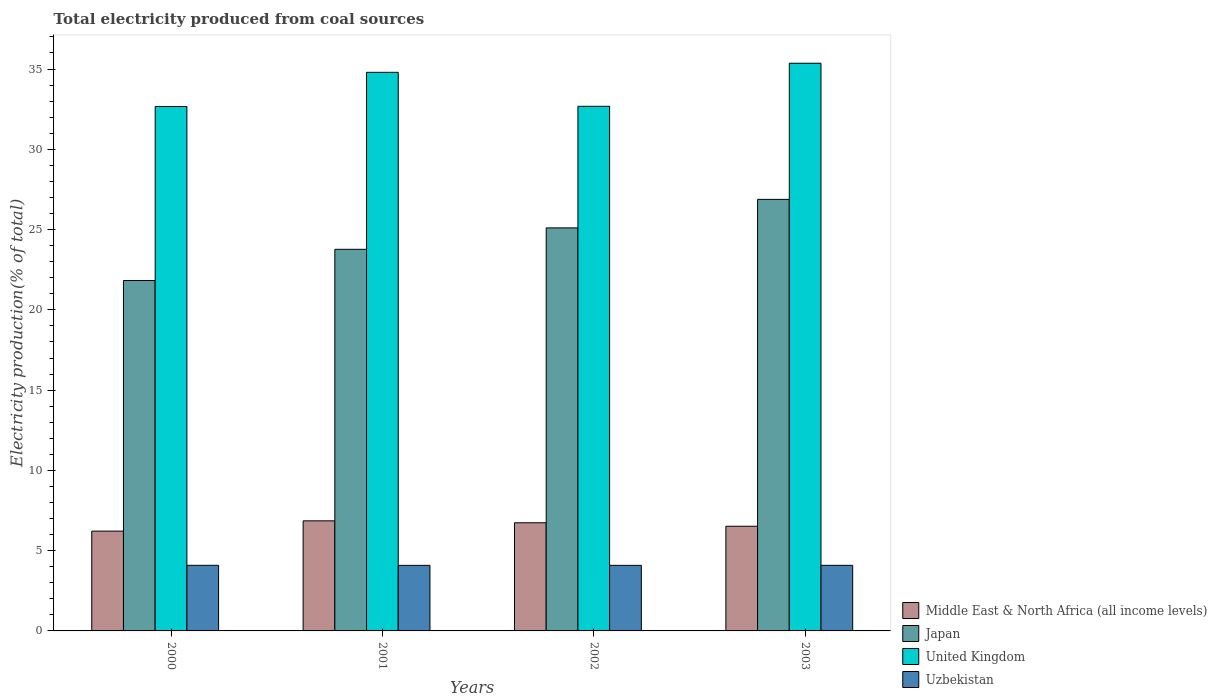How many different coloured bars are there?
Provide a succinct answer. 4. How many groups of bars are there?
Ensure brevity in your answer.  4. Are the number of bars on each tick of the X-axis equal?
Ensure brevity in your answer.  Yes. In how many cases, is the number of bars for a given year not equal to the number of legend labels?
Your answer should be very brief. 0. What is the total electricity produced in Middle East & North Africa (all income levels) in 2001?
Ensure brevity in your answer.  6.86. Across all years, what is the maximum total electricity produced in Japan?
Give a very brief answer. 26.88. Across all years, what is the minimum total electricity produced in Uzbekistan?
Your answer should be compact. 4.08. In which year was the total electricity produced in Uzbekistan maximum?
Ensure brevity in your answer.  2000. What is the total total electricity produced in United Kingdom in the graph?
Keep it short and to the point. 135.5. What is the difference between the total electricity produced in United Kingdom in 2001 and that in 2002?
Make the answer very short. 2.12. What is the difference between the total electricity produced in Japan in 2000 and the total electricity produced in United Kingdom in 2001?
Your answer should be very brief. -12.97. What is the average total electricity produced in Middle East & North Africa (all income levels) per year?
Make the answer very short. 6.58. In the year 2002, what is the difference between the total electricity produced in United Kingdom and total electricity produced in Japan?
Provide a succinct answer. 7.57. In how many years, is the total electricity produced in Uzbekistan greater than 10 %?
Provide a succinct answer. 0. What is the ratio of the total electricity produced in Uzbekistan in 2000 to that in 2002?
Keep it short and to the point. 1. Is the total electricity produced in United Kingdom in 2002 less than that in 2003?
Provide a succinct answer. Yes. What is the difference between the highest and the second highest total electricity produced in Japan?
Offer a terse response. 1.78. What is the difference between the highest and the lowest total electricity produced in United Kingdom?
Provide a succinct answer. 2.69. Is it the case that in every year, the sum of the total electricity produced in Middle East & North Africa (all income levels) and total electricity produced in Uzbekistan is greater than the sum of total electricity produced in United Kingdom and total electricity produced in Japan?
Make the answer very short. No. What does the 1st bar from the right in 2001 represents?
Your answer should be compact. Uzbekistan. Are all the bars in the graph horizontal?
Provide a short and direct response. No. What is the difference between two consecutive major ticks on the Y-axis?
Keep it short and to the point. 5. Are the values on the major ticks of Y-axis written in scientific E-notation?
Your answer should be compact. No. Does the graph contain any zero values?
Provide a short and direct response. No. Does the graph contain grids?
Ensure brevity in your answer.  No. Where does the legend appear in the graph?
Your answer should be compact. Bottom right. How many legend labels are there?
Provide a succinct answer. 4. What is the title of the graph?
Provide a short and direct response. Total electricity produced from coal sources. What is the Electricity production(% of total) in Middle East & North Africa (all income levels) in 2000?
Your response must be concise. 6.22. What is the Electricity production(% of total) of Japan in 2000?
Provide a short and direct response. 21.83. What is the Electricity production(% of total) in United Kingdom in 2000?
Provide a short and direct response. 32.67. What is the Electricity production(% of total) of Uzbekistan in 2000?
Give a very brief answer. 4.09. What is the Electricity production(% of total) of Middle East & North Africa (all income levels) in 2001?
Give a very brief answer. 6.86. What is the Electricity production(% of total) of Japan in 2001?
Your answer should be compact. 23.77. What is the Electricity production(% of total) of United Kingdom in 2001?
Ensure brevity in your answer.  34.8. What is the Electricity production(% of total) in Uzbekistan in 2001?
Keep it short and to the point. 4.08. What is the Electricity production(% of total) of Middle East & North Africa (all income levels) in 2002?
Give a very brief answer. 6.74. What is the Electricity production(% of total) of Japan in 2002?
Your response must be concise. 25.11. What is the Electricity production(% of total) in United Kingdom in 2002?
Make the answer very short. 32.68. What is the Electricity production(% of total) of Uzbekistan in 2002?
Make the answer very short. 4.08. What is the Electricity production(% of total) of Middle East & North Africa (all income levels) in 2003?
Make the answer very short. 6.52. What is the Electricity production(% of total) in Japan in 2003?
Offer a very short reply. 26.88. What is the Electricity production(% of total) of United Kingdom in 2003?
Offer a terse response. 35.36. What is the Electricity production(% of total) in Uzbekistan in 2003?
Your response must be concise. 4.09. Across all years, what is the maximum Electricity production(% of total) in Middle East & North Africa (all income levels)?
Offer a terse response. 6.86. Across all years, what is the maximum Electricity production(% of total) of Japan?
Ensure brevity in your answer.  26.88. Across all years, what is the maximum Electricity production(% of total) in United Kingdom?
Make the answer very short. 35.36. Across all years, what is the maximum Electricity production(% of total) of Uzbekistan?
Offer a very short reply. 4.09. Across all years, what is the minimum Electricity production(% of total) of Middle East & North Africa (all income levels)?
Make the answer very short. 6.22. Across all years, what is the minimum Electricity production(% of total) of Japan?
Your answer should be very brief. 21.83. Across all years, what is the minimum Electricity production(% of total) in United Kingdom?
Your answer should be compact. 32.67. Across all years, what is the minimum Electricity production(% of total) of Uzbekistan?
Give a very brief answer. 4.08. What is the total Electricity production(% of total) of Middle East & North Africa (all income levels) in the graph?
Keep it short and to the point. 26.33. What is the total Electricity production(% of total) of Japan in the graph?
Keep it short and to the point. 97.59. What is the total Electricity production(% of total) of United Kingdom in the graph?
Ensure brevity in your answer.  135.5. What is the total Electricity production(% of total) of Uzbekistan in the graph?
Offer a terse response. 16.34. What is the difference between the Electricity production(% of total) of Middle East & North Africa (all income levels) in 2000 and that in 2001?
Keep it short and to the point. -0.64. What is the difference between the Electricity production(% of total) of Japan in 2000 and that in 2001?
Offer a terse response. -1.94. What is the difference between the Electricity production(% of total) of United Kingdom in 2000 and that in 2001?
Make the answer very short. -2.13. What is the difference between the Electricity production(% of total) of Uzbekistan in 2000 and that in 2001?
Your response must be concise. 0. What is the difference between the Electricity production(% of total) in Middle East & North Africa (all income levels) in 2000 and that in 2002?
Provide a succinct answer. -0.52. What is the difference between the Electricity production(% of total) of Japan in 2000 and that in 2002?
Make the answer very short. -3.28. What is the difference between the Electricity production(% of total) of United Kingdom in 2000 and that in 2002?
Offer a terse response. -0.01. What is the difference between the Electricity production(% of total) of Uzbekistan in 2000 and that in 2002?
Ensure brevity in your answer.  0. What is the difference between the Electricity production(% of total) of Middle East & North Africa (all income levels) in 2000 and that in 2003?
Your answer should be very brief. -0.3. What is the difference between the Electricity production(% of total) in Japan in 2000 and that in 2003?
Your answer should be compact. -5.05. What is the difference between the Electricity production(% of total) in United Kingdom in 2000 and that in 2003?
Your response must be concise. -2.69. What is the difference between the Electricity production(% of total) in Uzbekistan in 2000 and that in 2003?
Your answer should be very brief. 0. What is the difference between the Electricity production(% of total) of Middle East & North Africa (all income levels) in 2001 and that in 2002?
Your response must be concise. 0.12. What is the difference between the Electricity production(% of total) in Japan in 2001 and that in 2002?
Keep it short and to the point. -1.33. What is the difference between the Electricity production(% of total) of United Kingdom in 2001 and that in 2002?
Provide a succinct answer. 2.12. What is the difference between the Electricity production(% of total) of Uzbekistan in 2001 and that in 2002?
Ensure brevity in your answer.  -0. What is the difference between the Electricity production(% of total) of Middle East & North Africa (all income levels) in 2001 and that in 2003?
Give a very brief answer. 0.34. What is the difference between the Electricity production(% of total) in Japan in 2001 and that in 2003?
Offer a very short reply. -3.11. What is the difference between the Electricity production(% of total) in United Kingdom in 2001 and that in 2003?
Your answer should be very brief. -0.56. What is the difference between the Electricity production(% of total) in Uzbekistan in 2001 and that in 2003?
Provide a short and direct response. -0. What is the difference between the Electricity production(% of total) in Middle East & North Africa (all income levels) in 2002 and that in 2003?
Make the answer very short. 0.22. What is the difference between the Electricity production(% of total) of Japan in 2002 and that in 2003?
Your response must be concise. -1.78. What is the difference between the Electricity production(% of total) in United Kingdom in 2002 and that in 2003?
Make the answer very short. -2.68. What is the difference between the Electricity production(% of total) in Uzbekistan in 2002 and that in 2003?
Keep it short and to the point. -0. What is the difference between the Electricity production(% of total) in Middle East & North Africa (all income levels) in 2000 and the Electricity production(% of total) in Japan in 2001?
Offer a very short reply. -17.55. What is the difference between the Electricity production(% of total) of Middle East & North Africa (all income levels) in 2000 and the Electricity production(% of total) of United Kingdom in 2001?
Your response must be concise. -28.58. What is the difference between the Electricity production(% of total) of Middle East & North Africa (all income levels) in 2000 and the Electricity production(% of total) of Uzbekistan in 2001?
Your response must be concise. 2.13. What is the difference between the Electricity production(% of total) of Japan in 2000 and the Electricity production(% of total) of United Kingdom in 2001?
Provide a short and direct response. -12.97. What is the difference between the Electricity production(% of total) in Japan in 2000 and the Electricity production(% of total) in Uzbekistan in 2001?
Your answer should be very brief. 17.74. What is the difference between the Electricity production(% of total) of United Kingdom in 2000 and the Electricity production(% of total) of Uzbekistan in 2001?
Ensure brevity in your answer.  28.58. What is the difference between the Electricity production(% of total) in Middle East & North Africa (all income levels) in 2000 and the Electricity production(% of total) in Japan in 2002?
Make the answer very short. -18.89. What is the difference between the Electricity production(% of total) of Middle East & North Africa (all income levels) in 2000 and the Electricity production(% of total) of United Kingdom in 2002?
Keep it short and to the point. -26.46. What is the difference between the Electricity production(% of total) in Middle East & North Africa (all income levels) in 2000 and the Electricity production(% of total) in Uzbekistan in 2002?
Your response must be concise. 2.13. What is the difference between the Electricity production(% of total) of Japan in 2000 and the Electricity production(% of total) of United Kingdom in 2002?
Offer a very short reply. -10.85. What is the difference between the Electricity production(% of total) of Japan in 2000 and the Electricity production(% of total) of Uzbekistan in 2002?
Make the answer very short. 17.74. What is the difference between the Electricity production(% of total) in United Kingdom in 2000 and the Electricity production(% of total) in Uzbekistan in 2002?
Your answer should be compact. 28.58. What is the difference between the Electricity production(% of total) in Middle East & North Africa (all income levels) in 2000 and the Electricity production(% of total) in Japan in 2003?
Keep it short and to the point. -20.66. What is the difference between the Electricity production(% of total) in Middle East & North Africa (all income levels) in 2000 and the Electricity production(% of total) in United Kingdom in 2003?
Your response must be concise. -29.14. What is the difference between the Electricity production(% of total) of Middle East & North Africa (all income levels) in 2000 and the Electricity production(% of total) of Uzbekistan in 2003?
Provide a short and direct response. 2.13. What is the difference between the Electricity production(% of total) of Japan in 2000 and the Electricity production(% of total) of United Kingdom in 2003?
Offer a very short reply. -13.53. What is the difference between the Electricity production(% of total) in Japan in 2000 and the Electricity production(% of total) in Uzbekistan in 2003?
Provide a succinct answer. 17.74. What is the difference between the Electricity production(% of total) in United Kingdom in 2000 and the Electricity production(% of total) in Uzbekistan in 2003?
Give a very brief answer. 28.58. What is the difference between the Electricity production(% of total) of Middle East & North Africa (all income levels) in 2001 and the Electricity production(% of total) of Japan in 2002?
Offer a very short reply. -18.25. What is the difference between the Electricity production(% of total) of Middle East & North Africa (all income levels) in 2001 and the Electricity production(% of total) of United Kingdom in 2002?
Your answer should be compact. -25.82. What is the difference between the Electricity production(% of total) in Middle East & North Africa (all income levels) in 2001 and the Electricity production(% of total) in Uzbekistan in 2002?
Provide a succinct answer. 2.77. What is the difference between the Electricity production(% of total) in Japan in 2001 and the Electricity production(% of total) in United Kingdom in 2002?
Make the answer very short. -8.91. What is the difference between the Electricity production(% of total) of Japan in 2001 and the Electricity production(% of total) of Uzbekistan in 2002?
Your answer should be compact. 19.69. What is the difference between the Electricity production(% of total) in United Kingdom in 2001 and the Electricity production(% of total) in Uzbekistan in 2002?
Provide a short and direct response. 30.71. What is the difference between the Electricity production(% of total) in Middle East & North Africa (all income levels) in 2001 and the Electricity production(% of total) in Japan in 2003?
Offer a terse response. -20.02. What is the difference between the Electricity production(% of total) in Middle East & North Africa (all income levels) in 2001 and the Electricity production(% of total) in United Kingdom in 2003?
Make the answer very short. -28.5. What is the difference between the Electricity production(% of total) in Middle East & North Africa (all income levels) in 2001 and the Electricity production(% of total) in Uzbekistan in 2003?
Your answer should be compact. 2.77. What is the difference between the Electricity production(% of total) in Japan in 2001 and the Electricity production(% of total) in United Kingdom in 2003?
Provide a succinct answer. -11.59. What is the difference between the Electricity production(% of total) of Japan in 2001 and the Electricity production(% of total) of Uzbekistan in 2003?
Make the answer very short. 19.69. What is the difference between the Electricity production(% of total) of United Kingdom in 2001 and the Electricity production(% of total) of Uzbekistan in 2003?
Your response must be concise. 30.71. What is the difference between the Electricity production(% of total) in Middle East & North Africa (all income levels) in 2002 and the Electricity production(% of total) in Japan in 2003?
Your response must be concise. -20.14. What is the difference between the Electricity production(% of total) in Middle East & North Africa (all income levels) in 2002 and the Electricity production(% of total) in United Kingdom in 2003?
Provide a short and direct response. -28.62. What is the difference between the Electricity production(% of total) of Middle East & North Africa (all income levels) in 2002 and the Electricity production(% of total) of Uzbekistan in 2003?
Make the answer very short. 2.65. What is the difference between the Electricity production(% of total) of Japan in 2002 and the Electricity production(% of total) of United Kingdom in 2003?
Keep it short and to the point. -10.26. What is the difference between the Electricity production(% of total) of Japan in 2002 and the Electricity production(% of total) of Uzbekistan in 2003?
Keep it short and to the point. 21.02. What is the difference between the Electricity production(% of total) in United Kingdom in 2002 and the Electricity production(% of total) in Uzbekistan in 2003?
Provide a succinct answer. 28.59. What is the average Electricity production(% of total) in Middle East & North Africa (all income levels) per year?
Your response must be concise. 6.58. What is the average Electricity production(% of total) of Japan per year?
Your response must be concise. 24.4. What is the average Electricity production(% of total) in United Kingdom per year?
Provide a short and direct response. 33.88. What is the average Electricity production(% of total) in Uzbekistan per year?
Make the answer very short. 4.08. In the year 2000, what is the difference between the Electricity production(% of total) of Middle East & North Africa (all income levels) and Electricity production(% of total) of Japan?
Your response must be concise. -15.61. In the year 2000, what is the difference between the Electricity production(% of total) of Middle East & North Africa (all income levels) and Electricity production(% of total) of United Kingdom?
Your response must be concise. -26.45. In the year 2000, what is the difference between the Electricity production(% of total) in Middle East & North Africa (all income levels) and Electricity production(% of total) in Uzbekistan?
Your answer should be very brief. 2.13. In the year 2000, what is the difference between the Electricity production(% of total) of Japan and Electricity production(% of total) of United Kingdom?
Provide a succinct answer. -10.84. In the year 2000, what is the difference between the Electricity production(% of total) of Japan and Electricity production(% of total) of Uzbekistan?
Provide a succinct answer. 17.74. In the year 2000, what is the difference between the Electricity production(% of total) in United Kingdom and Electricity production(% of total) in Uzbekistan?
Provide a succinct answer. 28.58. In the year 2001, what is the difference between the Electricity production(% of total) in Middle East & North Africa (all income levels) and Electricity production(% of total) in Japan?
Keep it short and to the point. -16.91. In the year 2001, what is the difference between the Electricity production(% of total) of Middle East & North Africa (all income levels) and Electricity production(% of total) of United Kingdom?
Your answer should be compact. -27.94. In the year 2001, what is the difference between the Electricity production(% of total) of Middle East & North Africa (all income levels) and Electricity production(% of total) of Uzbekistan?
Give a very brief answer. 2.77. In the year 2001, what is the difference between the Electricity production(% of total) in Japan and Electricity production(% of total) in United Kingdom?
Keep it short and to the point. -11.02. In the year 2001, what is the difference between the Electricity production(% of total) of Japan and Electricity production(% of total) of Uzbekistan?
Your response must be concise. 19.69. In the year 2001, what is the difference between the Electricity production(% of total) in United Kingdom and Electricity production(% of total) in Uzbekistan?
Provide a short and direct response. 30.71. In the year 2002, what is the difference between the Electricity production(% of total) in Middle East & North Africa (all income levels) and Electricity production(% of total) in Japan?
Your answer should be very brief. -18.37. In the year 2002, what is the difference between the Electricity production(% of total) of Middle East & North Africa (all income levels) and Electricity production(% of total) of United Kingdom?
Keep it short and to the point. -25.94. In the year 2002, what is the difference between the Electricity production(% of total) of Middle East & North Africa (all income levels) and Electricity production(% of total) of Uzbekistan?
Provide a succinct answer. 2.65. In the year 2002, what is the difference between the Electricity production(% of total) in Japan and Electricity production(% of total) in United Kingdom?
Make the answer very short. -7.57. In the year 2002, what is the difference between the Electricity production(% of total) in Japan and Electricity production(% of total) in Uzbekistan?
Your answer should be very brief. 21.02. In the year 2002, what is the difference between the Electricity production(% of total) in United Kingdom and Electricity production(% of total) in Uzbekistan?
Your answer should be very brief. 28.59. In the year 2003, what is the difference between the Electricity production(% of total) of Middle East & North Africa (all income levels) and Electricity production(% of total) of Japan?
Keep it short and to the point. -20.36. In the year 2003, what is the difference between the Electricity production(% of total) of Middle East & North Africa (all income levels) and Electricity production(% of total) of United Kingdom?
Make the answer very short. -28.84. In the year 2003, what is the difference between the Electricity production(% of total) in Middle East & North Africa (all income levels) and Electricity production(% of total) in Uzbekistan?
Make the answer very short. 2.44. In the year 2003, what is the difference between the Electricity production(% of total) in Japan and Electricity production(% of total) in United Kingdom?
Your answer should be compact. -8.48. In the year 2003, what is the difference between the Electricity production(% of total) of Japan and Electricity production(% of total) of Uzbekistan?
Provide a succinct answer. 22.8. In the year 2003, what is the difference between the Electricity production(% of total) in United Kingdom and Electricity production(% of total) in Uzbekistan?
Provide a succinct answer. 31.28. What is the ratio of the Electricity production(% of total) in Middle East & North Africa (all income levels) in 2000 to that in 2001?
Your answer should be compact. 0.91. What is the ratio of the Electricity production(% of total) of Japan in 2000 to that in 2001?
Provide a short and direct response. 0.92. What is the ratio of the Electricity production(% of total) of United Kingdom in 2000 to that in 2001?
Offer a terse response. 0.94. What is the ratio of the Electricity production(% of total) of Uzbekistan in 2000 to that in 2001?
Offer a terse response. 1. What is the ratio of the Electricity production(% of total) of Middle East & North Africa (all income levels) in 2000 to that in 2002?
Your response must be concise. 0.92. What is the ratio of the Electricity production(% of total) of Japan in 2000 to that in 2002?
Keep it short and to the point. 0.87. What is the ratio of the Electricity production(% of total) in United Kingdom in 2000 to that in 2002?
Your response must be concise. 1. What is the ratio of the Electricity production(% of total) of Uzbekistan in 2000 to that in 2002?
Make the answer very short. 1. What is the ratio of the Electricity production(% of total) in Middle East & North Africa (all income levels) in 2000 to that in 2003?
Make the answer very short. 0.95. What is the ratio of the Electricity production(% of total) of Japan in 2000 to that in 2003?
Make the answer very short. 0.81. What is the ratio of the Electricity production(% of total) of United Kingdom in 2000 to that in 2003?
Offer a very short reply. 0.92. What is the ratio of the Electricity production(% of total) in Middle East & North Africa (all income levels) in 2001 to that in 2002?
Offer a very short reply. 1.02. What is the ratio of the Electricity production(% of total) of Japan in 2001 to that in 2002?
Offer a very short reply. 0.95. What is the ratio of the Electricity production(% of total) in United Kingdom in 2001 to that in 2002?
Offer a very short reply. 1.06. What is the ratio of the Electricity production(% of total) in Uzbekistan in 2001 to that in 2002?
Provide a short and direct response. 1. What is the ratio of the Electricity production(% of total) in Middle East & North Africa (all income levels) in 2001 to that in 2003?
Offer a terse response. 1.05. What is the ratio of the Electricity production(% of total) in Japan in 2001 to that in 2003?
Give a very brief answer. 0.88. What is the ratio of the Electricity production(% of total) of United Kingdom in 2001 to that in 2003?
Keep it short and to the point. 0.98. What is the ratio of the Electricity production(% of total) in Middle East & North Africa (all income levels) in 2002 to that in 2003?
Ensure brevity in your answer.  1.03. What is the ratio of the Electricity production(% of total) of Japan in 2002 to that in 2003?
Provide a succinct answer. 0.93. What is the ratio of the Electricity production(% of total) of United Kingdom in 2002 to that in 2003?
Make the answer very short. 0.92. What is the difference between the highest and the second highest Electricity production(% of total) of Middle East & North Africa (all income levels)?
Offer a terse response. 0.12. What is the difference between the highest and the second highest Electricity production(% of total) of Japan?
Your answer should be very brief. 1.78. What is the difference between the highest and the second highest Electricity production(% of total) in United Kingdom?
Make the answer very short. 0.56. What is the difference between the highest and the second highest Electricity production(% of total) in Uzbekistan?
Give a very brief answer. 0. What is the difference between the highest and the lowest Electricity production(% of total) in Middle East & North Africa (all income levels)?
Keep it short and to the point. 0.64. What is the difference between the highest and the lowest Electricity production(% of total) of Japan?
Offer a terse response. 5.05. What is the difference between the highest and the lowest Electricity production(% of total) in United Kingdom?
Ensure brevity in your answer.  2.69. What is the difference between the highest and the lowest Electricity production(% of total) of Uzbekistan?
Offer a terse response. 0. 